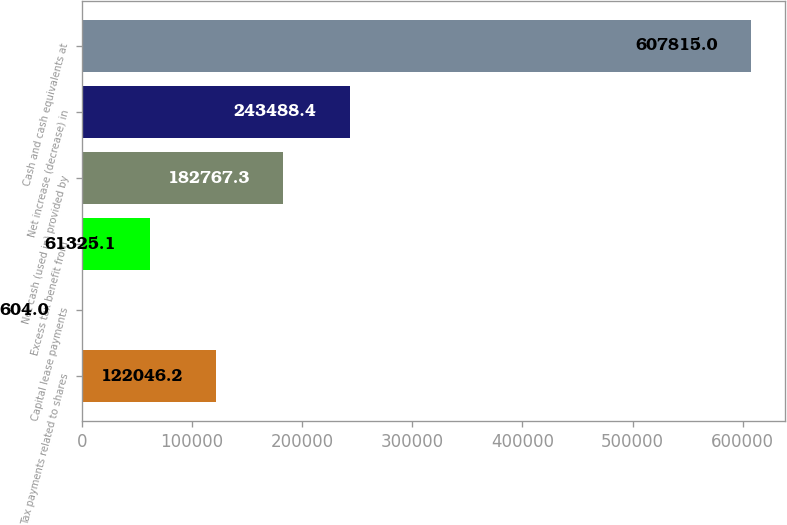Convert chart. <chart><loc_0><loc_0><loc_500><loc_500><bar_chart><fcel>Tax payments related to shares<fcel>Capital lease payments<fcel>Excess tax benefit from<fcel>Net cash (used in) provided by<fcel>Net increase (decrease) in<fcel>Cash and cash equivalents at<nl><fcel>122046<fcel>604<fcel>61325.1<fcel>182767<fcel>243488<fcel>607815<nl></chart> 